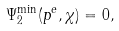<formula> <loc_0><loc_0><loc_500><loc_500>\Psi _ { 2 } ^ { \min } ( p ^ { e } , \chi ) = 0 ,</formula> 